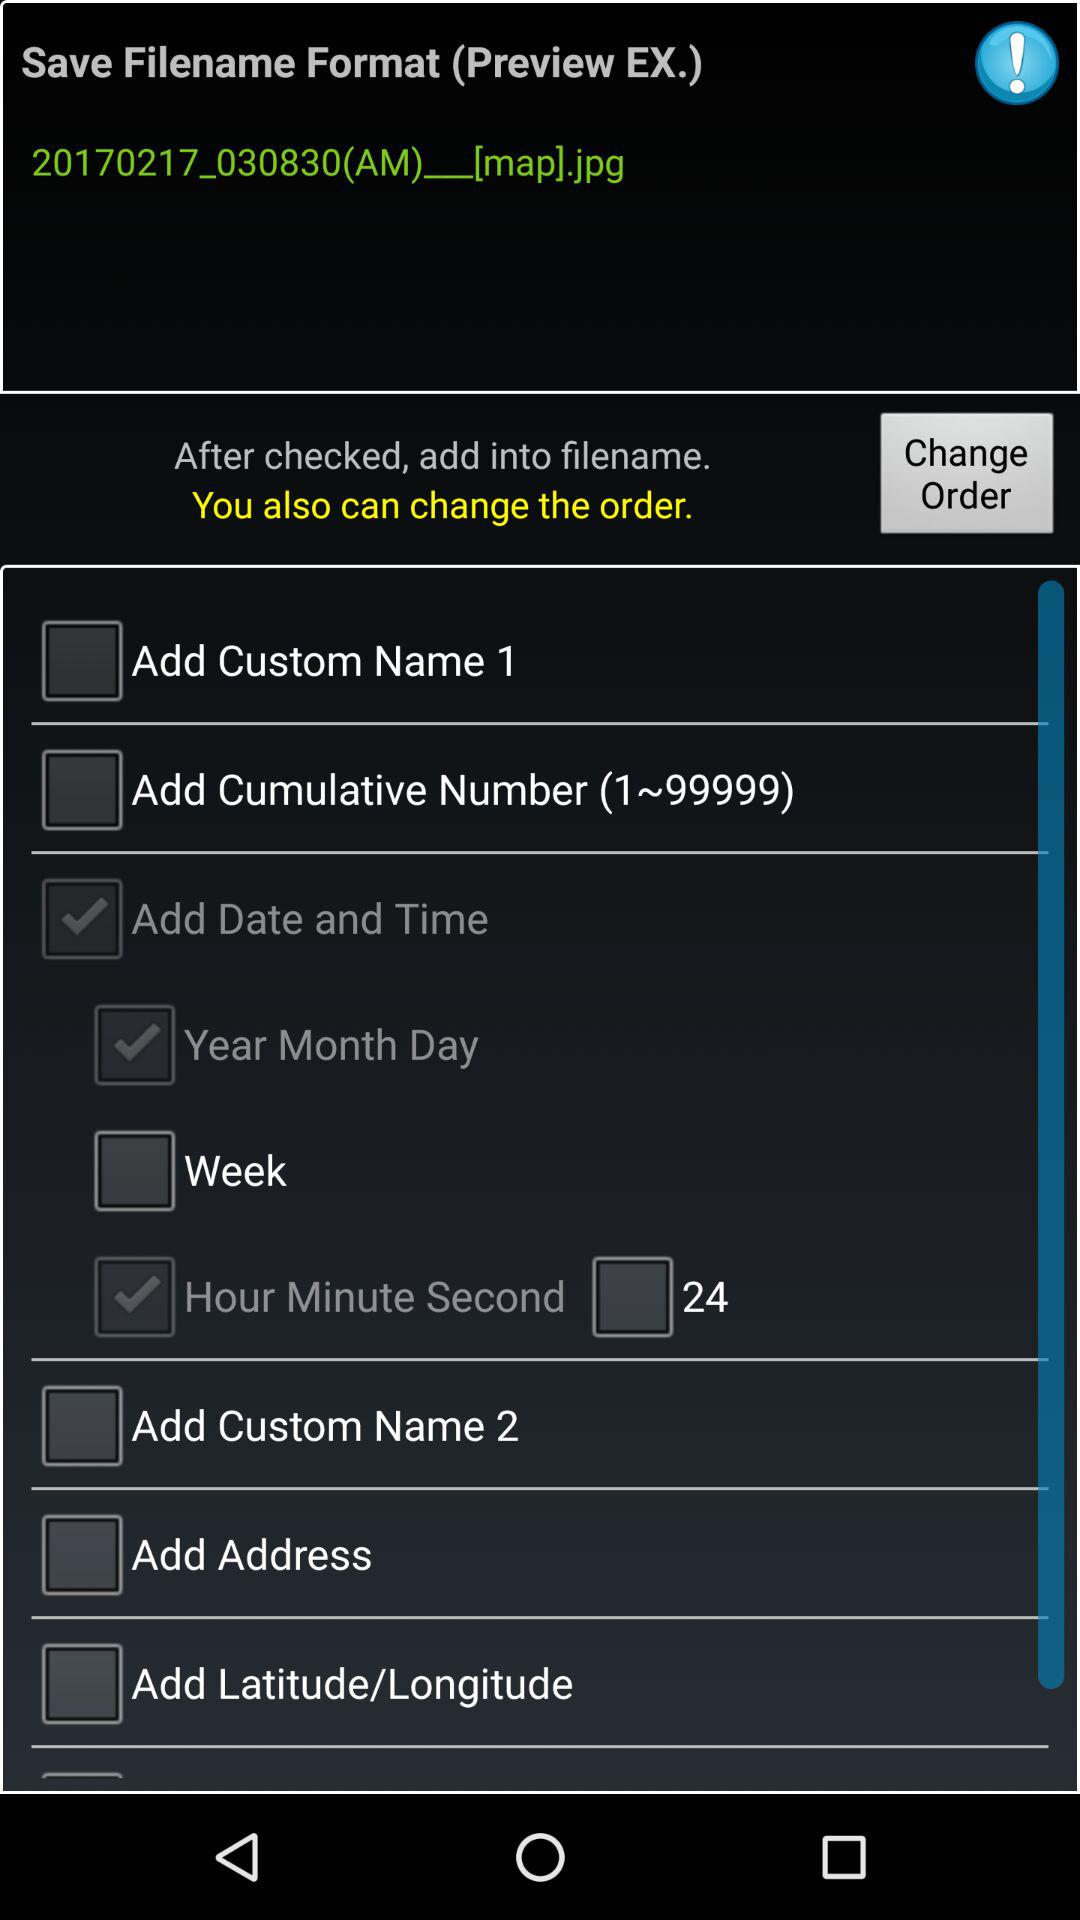What is the status of "Week"? The status is "off". 